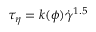<formula> <loc_0><loc_0><loc_500><loc_500>{ { \tau } _ { \eta } } = k ( \phi ) { { \dot { \gamma } } ^ { 1 . 5 } }</formula> 